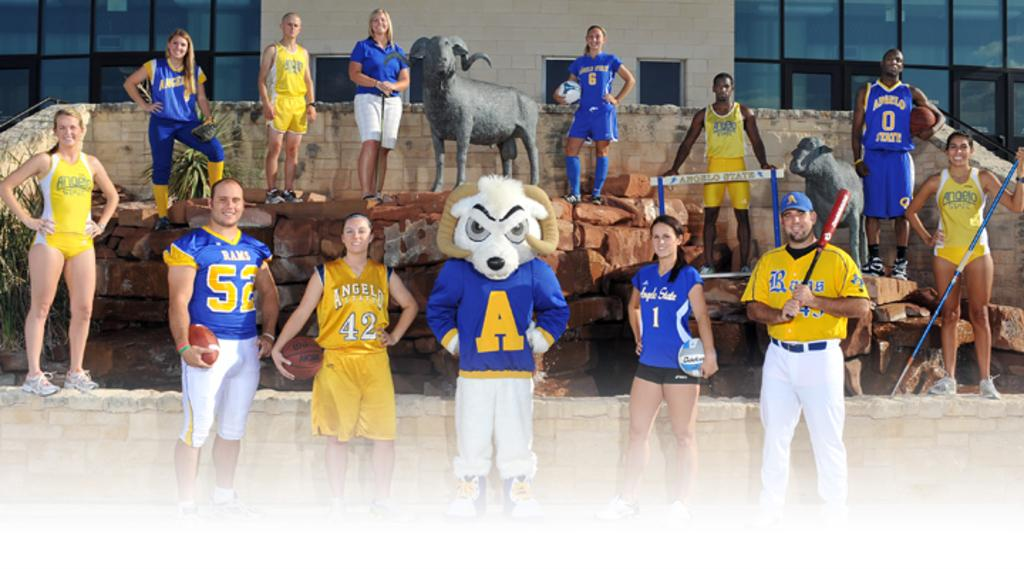<image>
Present a compact description of the photo's key features. Mascot wearing a blue shirt that has the letter A  on it. 